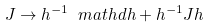Convert formula to latex. <formula><loc_0><loc_0><loc_500><loc_500>J \to h ^ { - 1 } \ m a t h d h + h ^ { - 1 } J h</formula> 